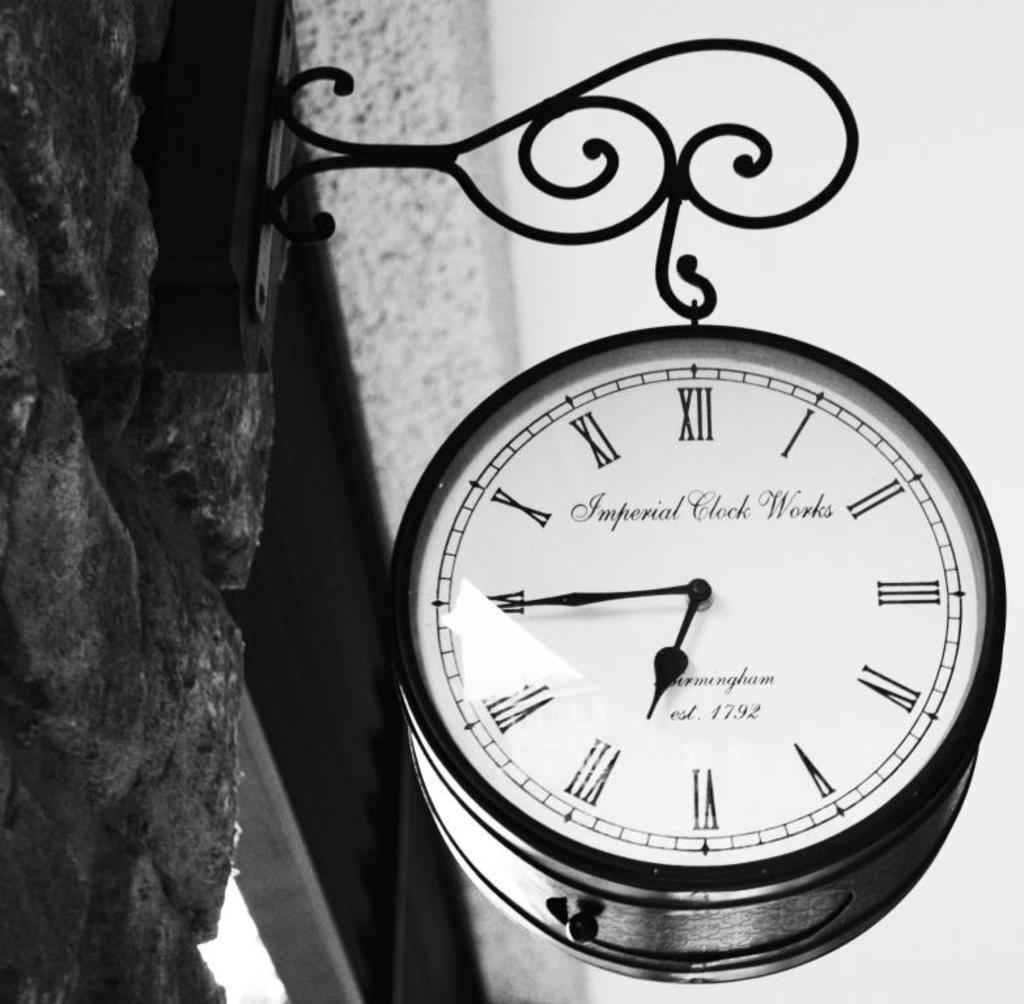<image>
Describe the image concisely. A clock hanging from a building made by Imperial Clock Works. 